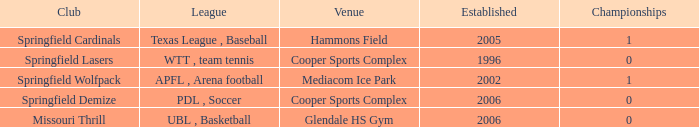What are the top championships involving the springfield cardinals club? 1.0. 